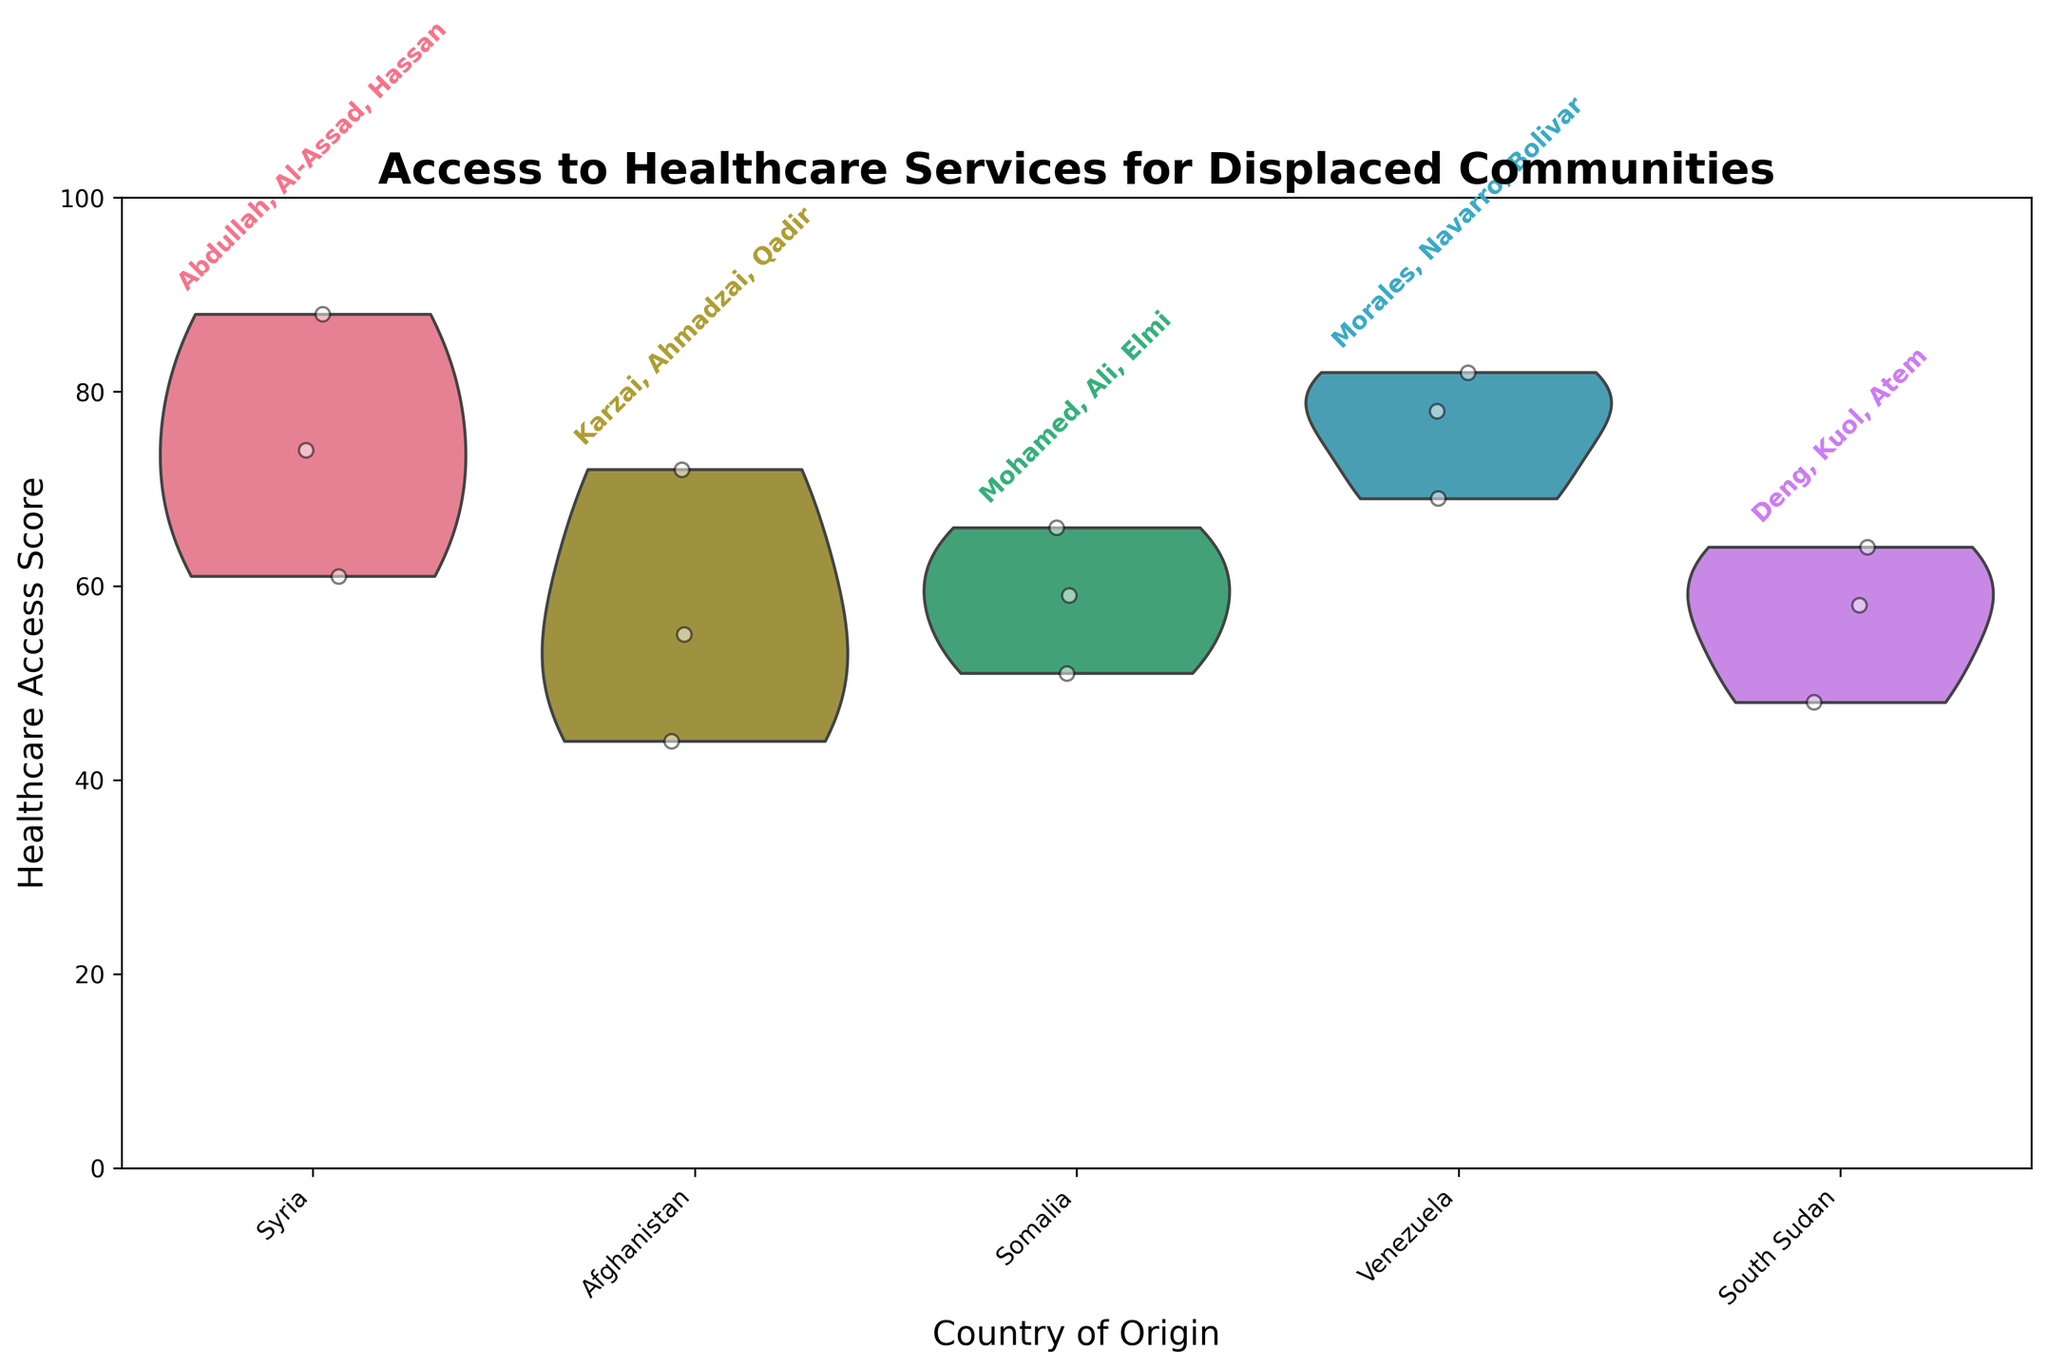What is the title of the figure? The title of the figure is typically displayed at the top of the plot and provides a summary of the content and purpose of the chart. In this case, it introduces the topic being visualized.
Answer: Access to Healthcare Services for Displaced Communities Which country has the highest healthcare access score? The highest value of the violin plots and scatter points within each country's category represents the peak healthcare access score. By scanning vertically, we identify that Syria has the highest peak at 88.
Answer: Syria How many communities are represented in the Venezuela group? Each jittered point within the Venezuela category represents a community. Counting these points will reveal the number of communities. There are 3 points for Venezuela.
Answer: 3 How is healthcare access distributed among Afghan communities? The violin plot for Afghanistan displays the distribution, while the jittered points show exact scores. The distribution includes one lower outlier and two scores higher.
Answer: Scores range from 44 to 72, mostly centered around the mid-values Which country shows the widest range of healthcare access scores? Observing the spread of the violin plots, one can see that the country with the widest vertical range has the broadest distribution of healthcare scores. Afghanistan shows the widest range from 44 to 72.
Answer: Afghanistan Are there any countries where the jittered points are tightly clustered? Tightly clustered points indicate little variance in healthcare scores. For example, Somalia's points are relatively close together between 51 and 66.
Answer: Somalia What is the lowest healthcare access score shown in the plot? The lowest point across all jittered scatter points represents the floor healthcare access score. The lowest value on the plot is 44 for Afghanistan.
Answer: 44 Compare the median access scores of South Sudan and Syria. Medians can be inferred from the central bulge of the violin plot. South Sudan has a narrower density around its center than Syria. Syria's central values are higher, so Syria has a higher median.
Answer: Syria has a higher median For which country is the spread of healthcare access scores the most symmetric? A symmetric spread in a violin plot means similar bulge shapes above and below the median. Afghanistan shows relatively symmetric spread around its median score.
Answer: Afghanistan Explain the role of colors in identifying countries of origin. Different colors for violin plots visually differentiate between countries. Each country has a unique color, aiding in distinguishing distributions without overlapping information.
Answer: Unique colors per country 